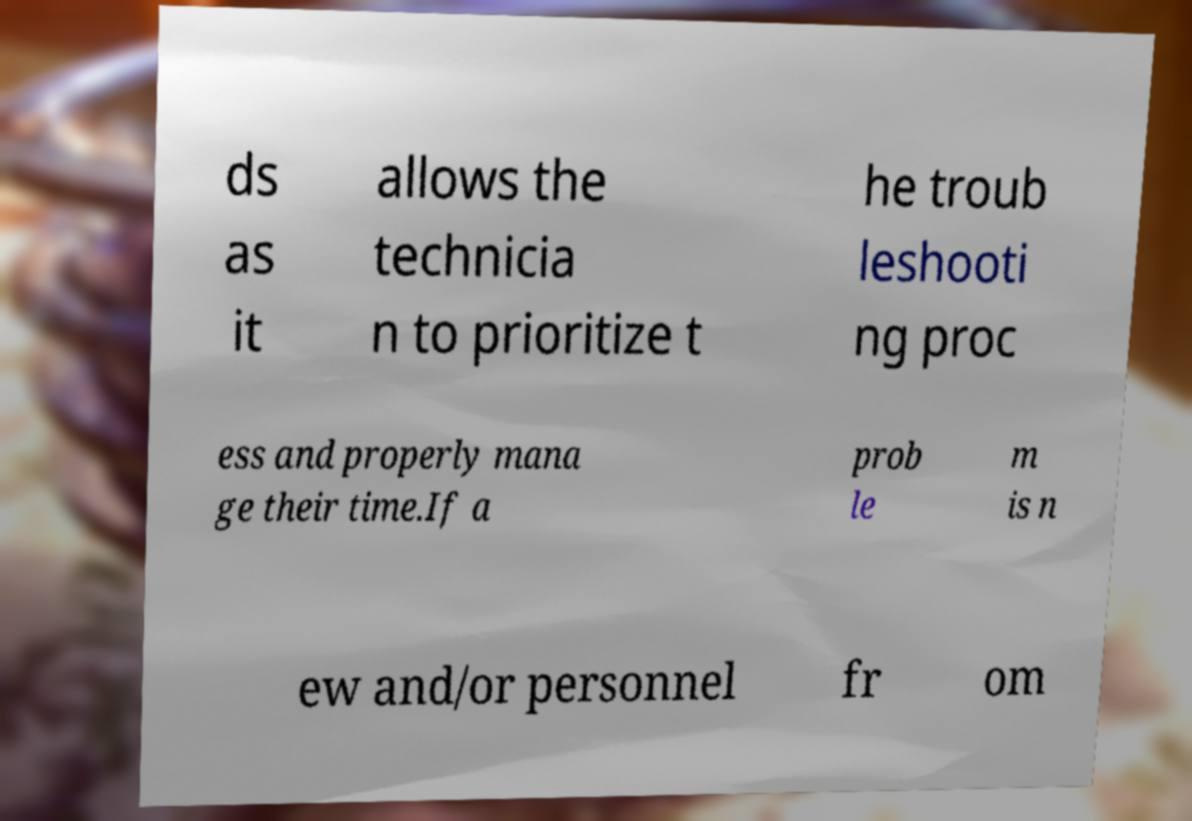There's text embedded in this image that I need extracted. Can you transcribe it verbatim? ds as it allows the technicia n to prioritize t he troub leshooti ng proc ess and properly mana ge their time.If a prob le m is n ew and/or personnel fr om 